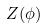<formula> <loc_0><loc_0><loc_500><loc_500>Z ( \phi )</formula> 